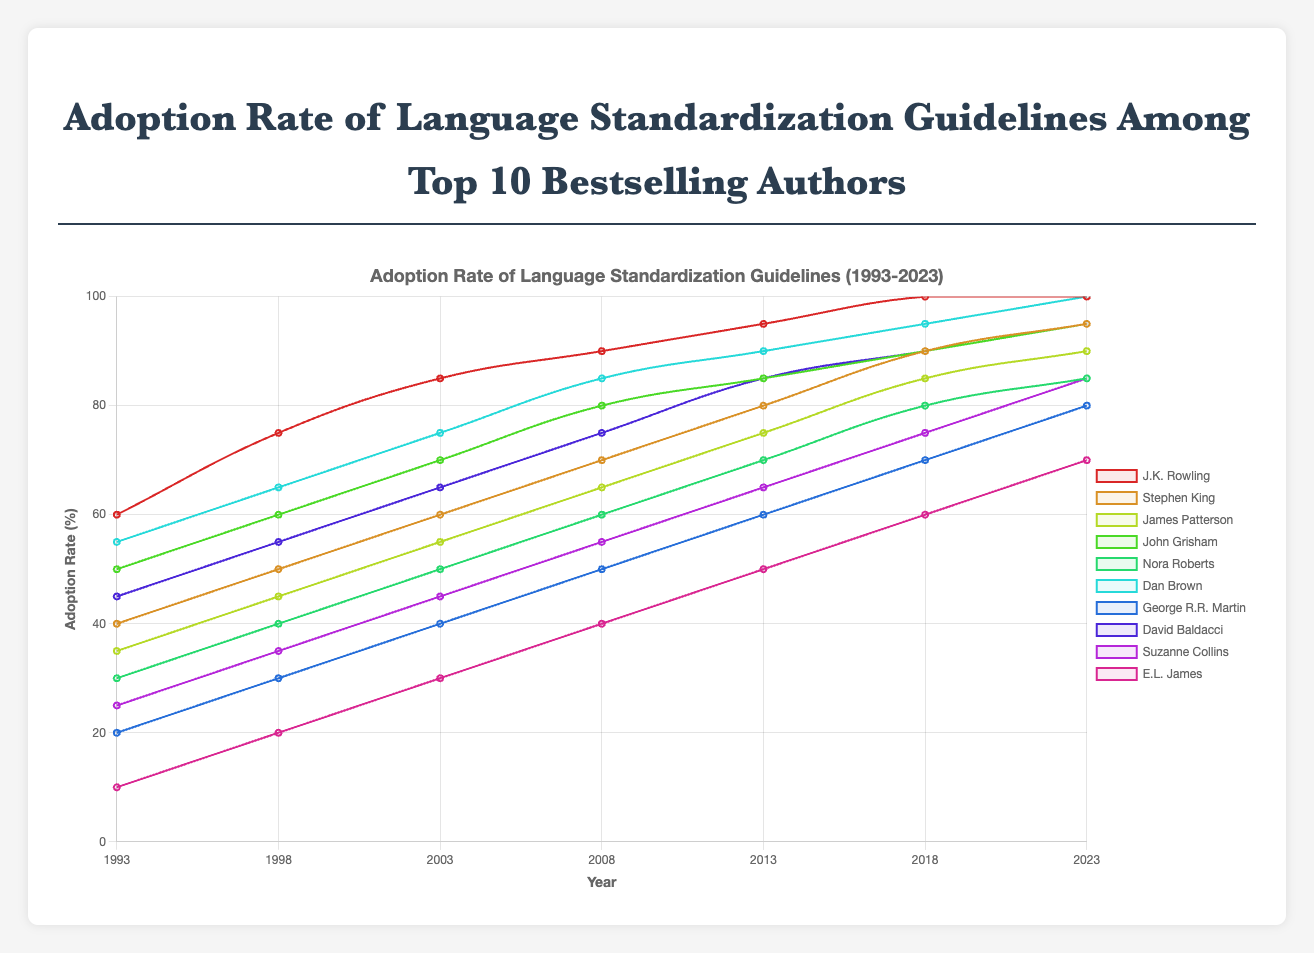What was the adoption rate of language standardization guidelines for J.K. Rowling in 2003? Find the adoption rate of J.K. Rowling corresponding to the year 2003 in the chart, which is 85%.
Answer: 85% Whose adoption rate of language standardization guidelines increased the most from 1993 to 2023? Calculate the difference between the adoption rates of 2023 and 1993 for each author. J.K. Rowling and Dan Brown had the same maximum increase from 60% to 100%, which is 40 percentage points.
Answer: J.K. Rowling and Dan Brown Which author had the lowest adoption rate in 1993? Observe the graph and find the author whose adoption rate is the lowest in 1993, which is E.L. James with 10%.
Answer: E.L. James What is the average adoption rate of language standardization for Dan Brown from 1993 to 2023? Sum the adoption rates for Dan Brown over the years (55 + 65 + 75 + 85 + 90 + 95 + 100) = 565, and divide by the number of years, 7. So, average = 565 / 7 = 80.7.
Answer: 80.7 Did Stephen King reach a 90% adoption rate before 2018? Look for the first year when Stephen King's adoption rate is 90% or higher. In 2018, his rate is exactly 90%.
Answer: Yes Compare the adoption rates of James Patterson and John Grisham in 2013. Who had the higher rate? For the year 2013, James Patterson's adoption rate is 75%, and John Grisham's is 85%. John Grisham had the higher rate.
Answer: John Grisham What was the trend of George R.R. Martin's adoption rate from 1993 to 2023? Examine the line corresponding to George R.R. Martin and notice the increasing trend from 20% in 1993 to 80% in 2023.
Answer: Increasing What is the sum of the adoption rates for Nora Roberts in 1993, 2003, and 2013? Add the adoption rates for the relevant years: 30 (1993) + 50 (2003) + 70 (2013) = 150.
Answer: 150 Which author had a 100% adoption rate in 2023 and what were their rates in the previous year, 2018? Identify the authors with 100% in 2023: J.K. Rowling and Dan Brown. In 2018, J.K. Rowling had 100%, and Dan Brown had 95%.
Answer: J.K. Rowling (100%) and Dan Brown (95%) Who had the larger increase in adoption rate from 2008 to 2013, David Baldacci, or Suzanne Collins? Calculate the difference for David Baldacci (85 - 75 = 10) and Suzanne Collins (65 - 55 = 10). Both had the same increase of 10 percentage points.
Answer: Same increase 